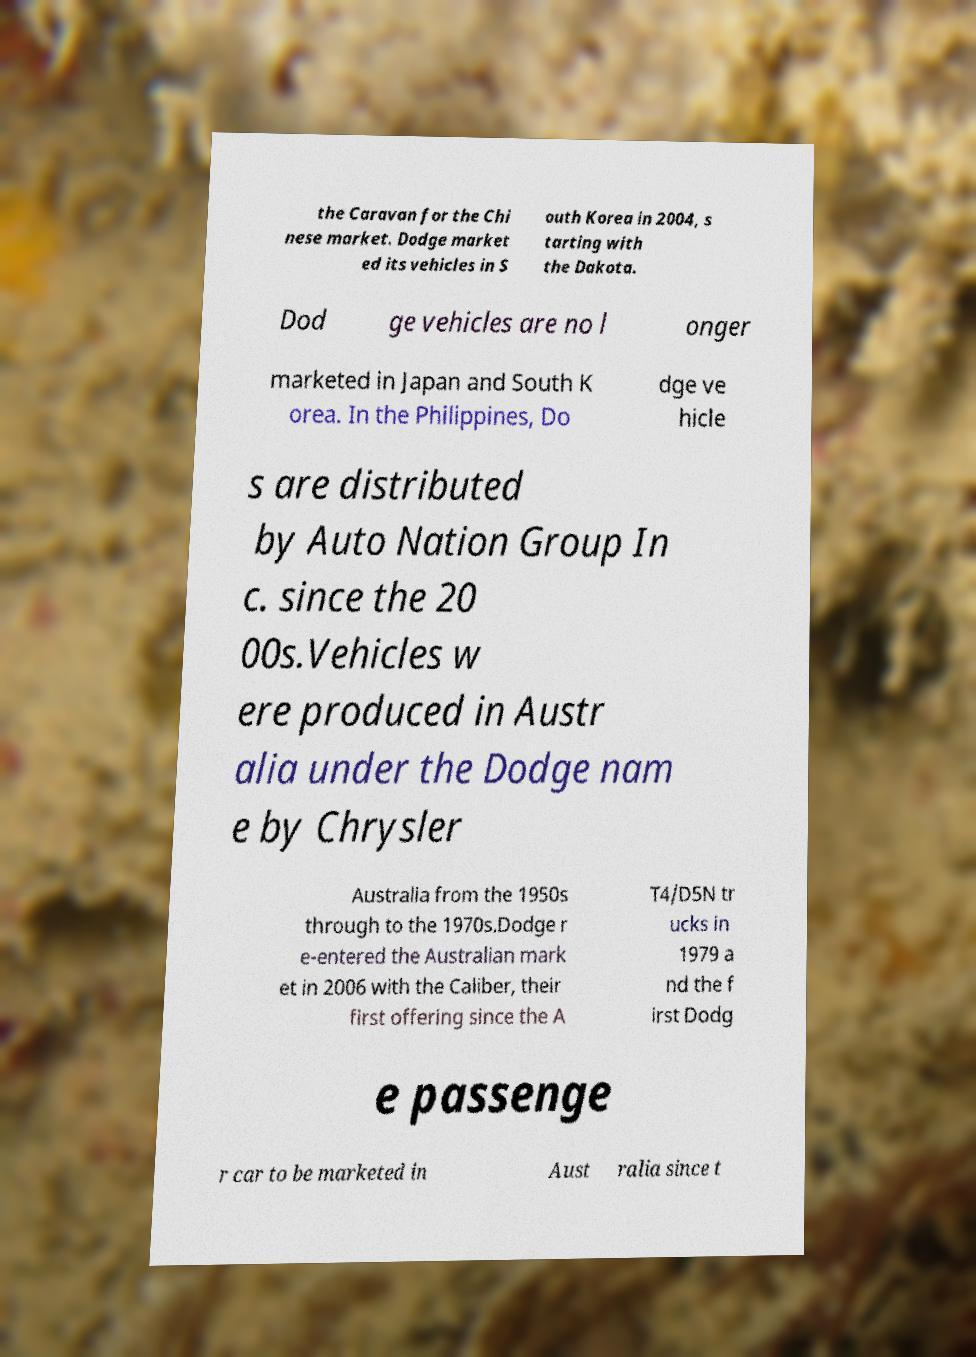Please read and relay the text visible in this image. What does it say? the Caravan for the Chi nese market. Dodge market ed its vehicles in S outh Korea in 2004, s tarting with the Dakota. Dod ge vehicles are no l onger marketed in Japan and South K orea. In the Philippines, Do dge ve hicle s are distributed by Auto Nation Group In c. since the 20 00s.Vehicles w ere produced in Austr alia under the Dodge nam e by Chrysler Australia from the 1950s through to the 1970s.Dodge r e-entered the Australian mark et in 2006 with the Caliber, their first offering since the A T4/D5N tr ucks in 1979 a nd the f irst Dodg e passenge r car to be marketed in Aust ralia since t 